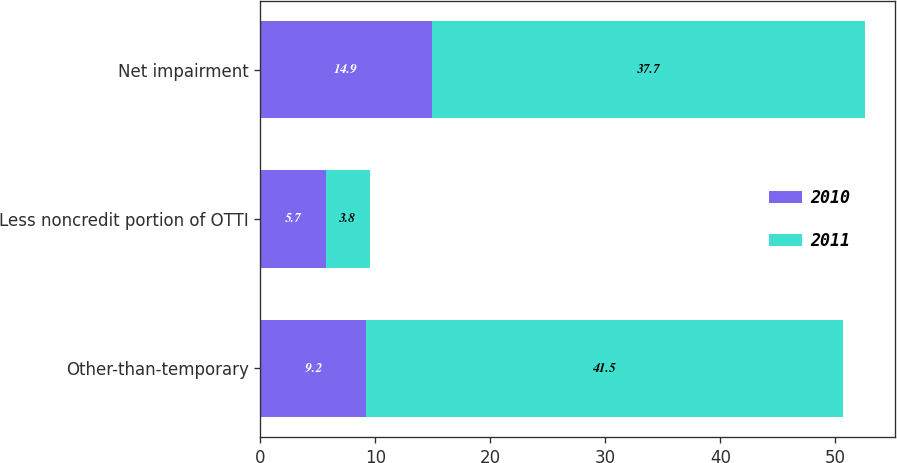<chart> <loc_0><loc_0><loc_500><loc_500><stacked_bar_chart><ecel><fcel>Other-than-temporary<fcel>Less noncredit portion of OTTI<fcel>Net impairment<nl><fcel>2010<fcel>9.2<fcel>5.7<fcel>14.9<nl><fcel>2011<fcel>41.5<fcel>3.8<fcel>37.7<nl></chart> 